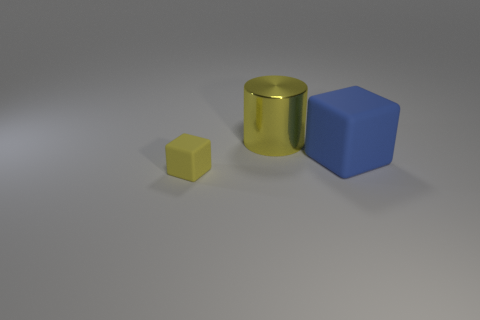Is there anything else that is the same shape as the yellow metallic object?
Offer a terse response. No. Are there any other things that have the same size as the yellow rubber object?
Give a very brief answer. No. Does the small yellow object have the same shape as the yellow thing that is behind the tiny matte object?
Offer a very short reply. No. There is a object that is to the left of the large blue rubber cube and behind the small yellow cube; what color is it?
Ensure brevity in your answer.  Yellow. Is there another tiny object of the same shape as the blue rubber object?
Give a very brief answer. Yes. Does the large cylinder have the same color as the large matte block?
Offer a very short reply. No. There is a cube behind the yellow rubber object; is there a yellow cylinder in front of it?
Provide a short and direct response. No. What number of objects are either cubes on the right side of the yellow metal thing or tiny yellow rubber blocks that are left of the blue thing?
Make the answer very short. 2. How many objects are either large metallic cylinders or matte blocks right of the yellow block?
Provide a short and direct response. 2. There is a cube that is right of the big object to the left of the blue matte cube behind the tiny block; what size is it?
Your answer should be compact. Large. 